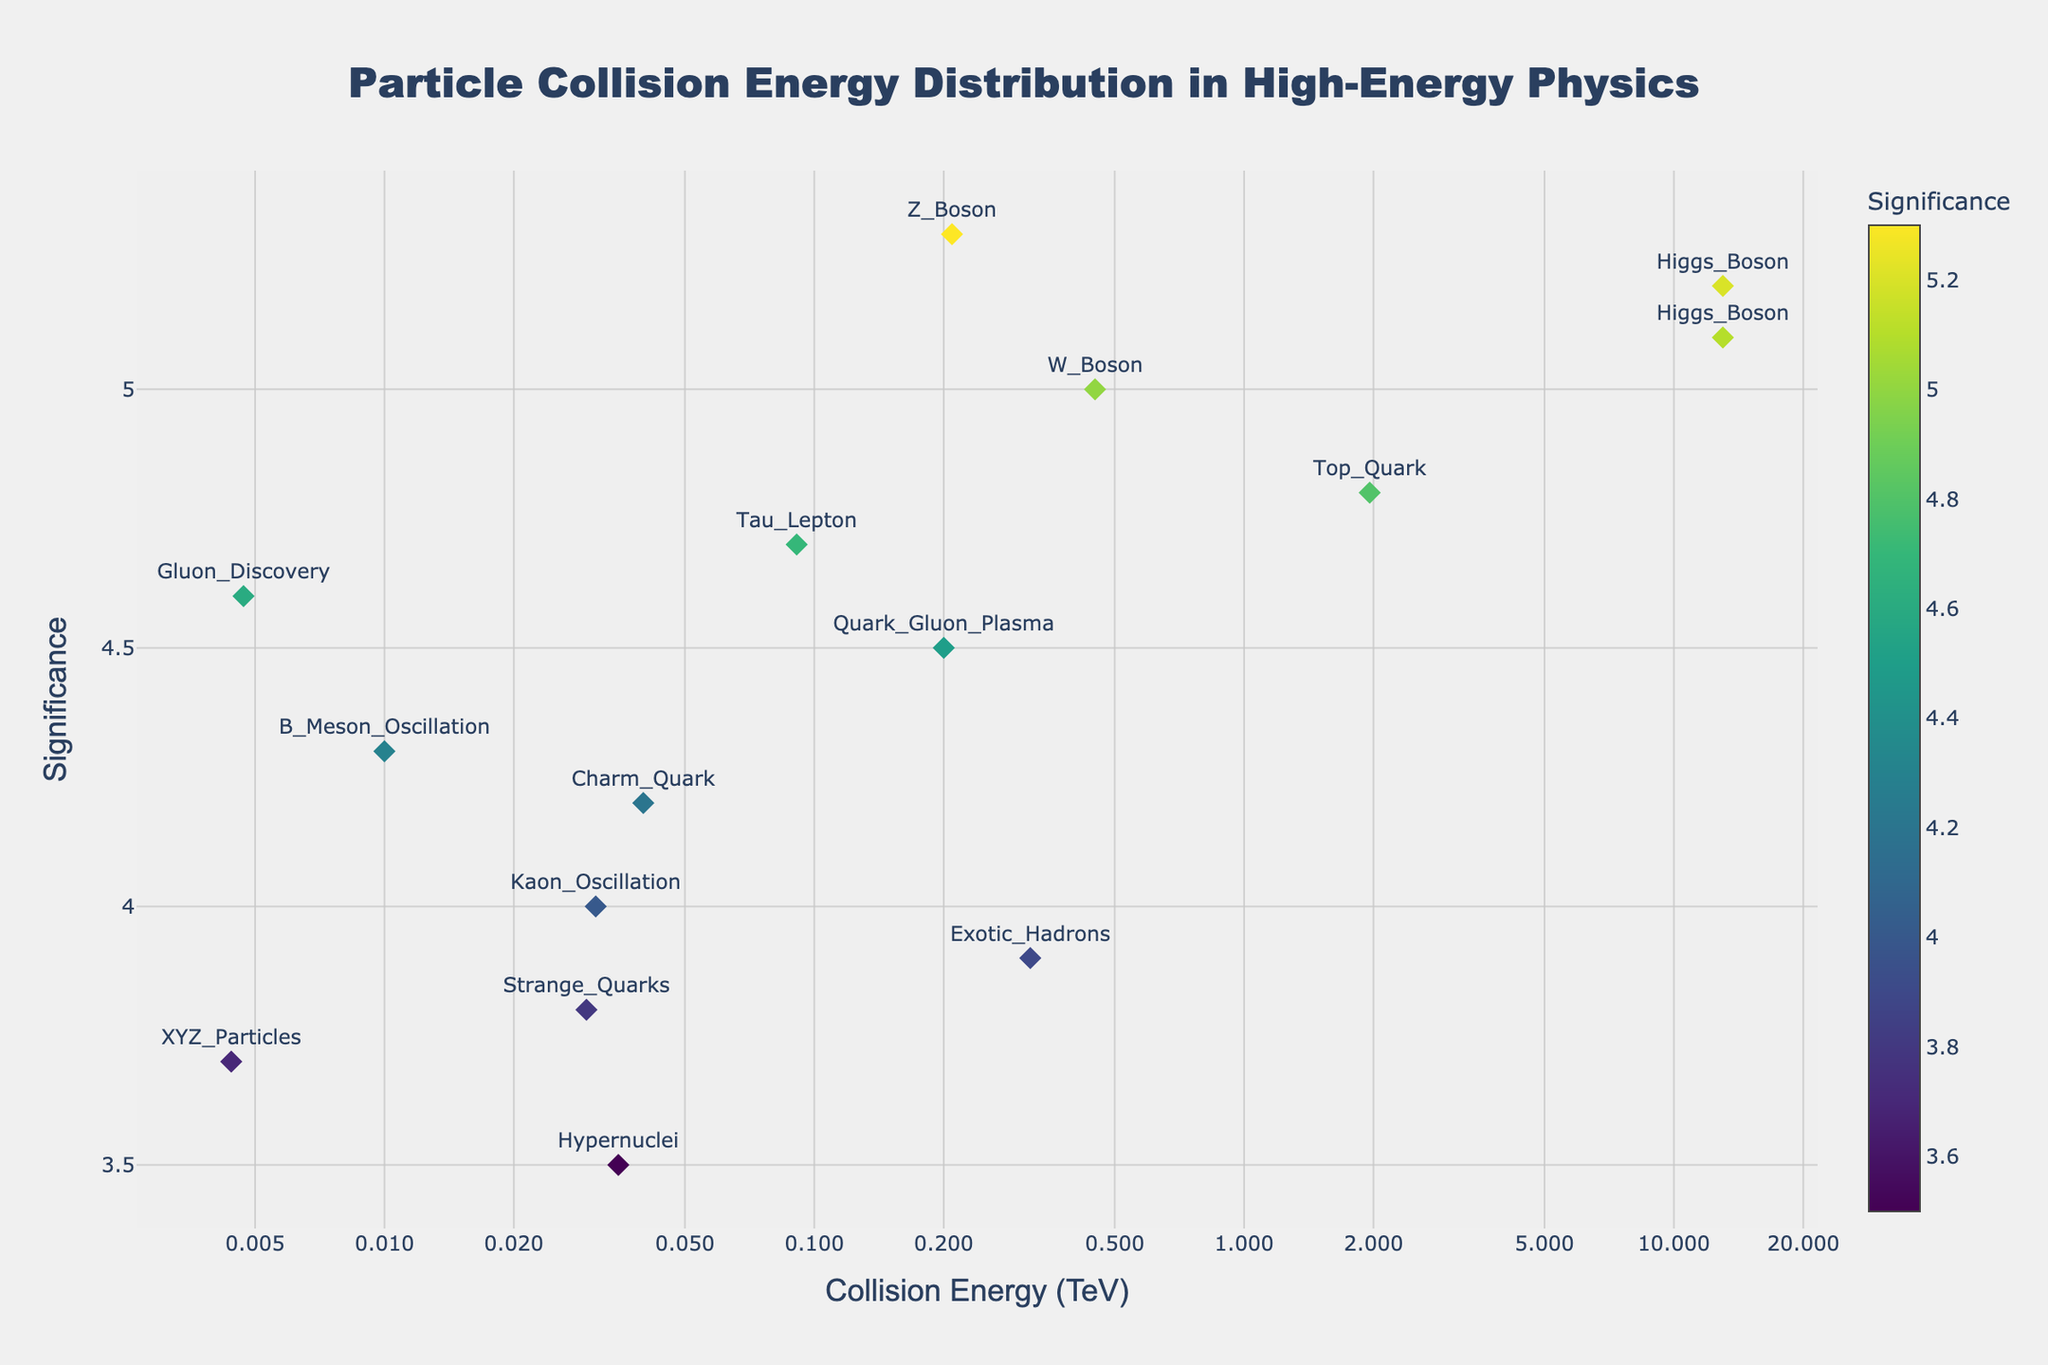What is the title of the plot? The title of the plot is located at the top center of the figure in a large font. It is "Particle Collision Energy Distribution in High-Energy Physics."
Answer: Particle Collision Energy Distribution in High-Energy Physics Which experiment shows a collision energy of 0.2 TeV? To find the experiment with a collision energy of 0.2 TeV, locate this value on the x-axis and look for the corresponding data point. The hover text provides details, showing it as RHIC with a collision energy of 0.2 TeV.
Answer: RHIC What is the highest significance value, and which particle type does it correspond to? To determine the highest significance value, find the highest y-axis value on the Manhattan plot. The highest significance shown is 5.3, which corresponds to the Z Boson.
Answer: 5.3, Z Boson How many experiments have a significance value greater than 5? To answer this, count the number of data points on the plot with a significance value (y-axis) greater than 5. There are three such data points: one for Higgs Boson (ATLAS and CMS), and one for Z Boson (LEP).
Answer: Three Which particle type corresponds to the lowest collision energy, and what is its significance value? The lowest collision energy is found at the smallest value on the x-axis. This corresponds to a collision energy of 0.0044 TeV, linked to the particle type XYZ Particles with a significance value of 3.7.
Answer: XYZ Particles, 3.7 What is the sum of collision energies for the experiments with significance values between 4 and 5? First, identify the data points with significance values between 4 and 5, which include six points: Top Quark (Tevatron, 1.96 TeV), Tau Lepton (SLAC, 0.091 TeV), Charm Quark (Fermilab, 0.04 TeV), Kaon Oscillation (J-PARC, 0.031 TeV), Gluon Discovery (DESY, 0.0047 TeV), and B Meson Oscillation (KEK, 0.01 TeV). Sum these collision energies: 1.96 + 0.091 + 0.04 + 0.031 + 0.0047 + 0.01 = 2.1367 TeV.
Answer: 2.1367 TeV Which experiment has the lowest significance value, and what particle type does it measure? To identify the experiment with the lowest significance value, look for the smallest value on the y-axis. The lowest significance value is 3.5, which corresponds to the FAIR experiment measuring Hypernuclei.
Answer: FAIR, Hypernuclei Compare the significance of the W Boson discovery at CERN_SPS with that of the Higgs Boson discovery at LHC_ATLAS and LHC_CMS. To compare, locate the W Boson (5.0 significance) and Higgs Boson entries (both at 5.2 and 5.1 significance). The significance of the W Boson discovery (5.0) is slightly less than that of the Higgs Boson discoveries (5.2 and 5.1).
Answer: W Boson is less significant than Higgs Boson 